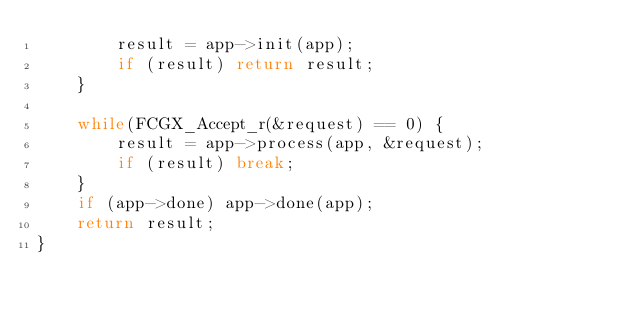Convert code to text. <code><loc_0><loc_0><loc_500><loc_500><_C_>        result = app->init(app);
        if (result) return result;
    }

    while(FCGX_Accept_r(&request) == 0) {
        result = app->process(app, &request);
        if (result) break;
    }
    if (app->done) app->done(app);
    return result;
}
</code> 